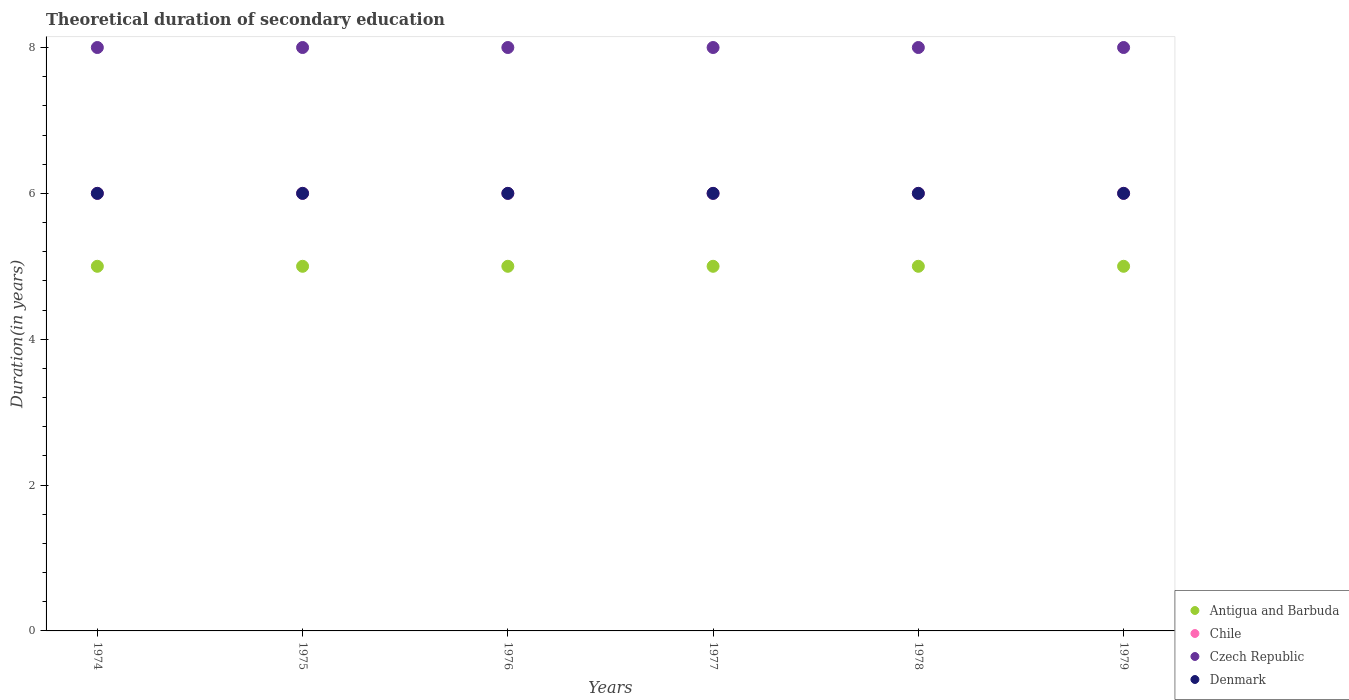How many different coloured dotlines are there?
Offer a terse response. 4. Is the number of dotlines equal to the number of legend labels?
Your answer should be very brief. Yes. What is the total theoretical duration of secondary education in Denmark in 1974?
Your answer should be compact. 6. Across all years, what is the minimum total theoretical duration of secondary education in Czech Republic?
Make the answer very short. 8. In which year was the total theoretical duration of secondary education in Antigua and Barbuda maximum?
Provide a short and direct response. 1974. In which year was the total theoretical duration of secondary education in Czech Republic minimum?
Provide a short and direct response. 1974. What is the total total theoretical duration of secondary education in Czech Republic in the graph?
Keep it short and to the point. 48. What is the difference between the total theoretical duration of secondary education in Denmark in 1979 and the total theoretical duration of secondary education in Czech Republic in 1974?
Ensure brevity in your answer.  -2. What is the average total theoretical duration of secondary education in Denmark per year?
Make the answer very short. 6. In the year 1974, what is the difference between the total theoretical duration of secondary education in Czech Republic and total theoretical duration of secondary education in Denmark?
Your answer should be compact. 2. What is the ratio of the total theoretical duration of secondary education in Czech Republic in 1976 to that in 1977?
Offer a very short reply. 1. Is the difference between the total theoretical duration of secondary education in Czech Republic in 1975 and 1976 greater than the difference between the total theoretical duration of secondary education in Denmark in 1975 and 1976?
Provide a short and direct response. No. What is the difference between the highest and the lowest total theoretical duration of secondary education in Antigua and Barbuda?
Keep it short and to the point. 0. Is it the case that in every year, the sum of the total theoretical duration of secondary education in Czech Republic and total theoretical duration of secondary education in Denmark  is greater than the sum of total theoretical duration of secondary education in Chile and total theoretical duration of secondary education in Antigua and Barbuda?
Offer a terse response. Yes. Does the total theoretical duration of secondary education in Chile monotonically increase over the years?
Your answer should be compact. No. Is the total theoretical duration of secondary education in Antigua and Barbuda strictly greater than the total theoretical duration of secondary education in Czech Republic over the years?
Make the answer very short. No. Is the total theoretical duration of secondary education in Denmark strictly less than the total theoretical duration of secondary education in Czech Republic over the years?
Offer a terse response. Yes. How many years are there in the graph?
Keep it short and to the point. 6. Are the values on the major ticks of Y-axis written in scientific E-notation?
Make the answer very short. No. Does the graph contain grids?
Your answer should be very brief. No. What is the title of the graph?
Your response must be concise. Theoretical duration of secondary education. What is the label or title of the Y-axis?
Provide a succinct answer. Duration(in years). What is the Duration(in years) in Chile in 1974?
Give a very brief answer. 6. What is the Duration(in years) of Antigua and Barbuda in 1975?
Provide a succinct answer. 5. What is the Duration(in years) in Chile in 1975?
Make the answer very short. 6. What is the Duration(in years) in Chile in 1976?
Provide a short and direct response. 6. What is the Duration(in years) in Antigua and Barbuda in 1977?
Offer a very short reply. 5. What is the Duration(in years) of Chile in 1977?
Keep it short and to the point. 6. What is the Duration(in years) of Czech Republic in 1978?
Give a very brief answer. 8. What is the Duration(in years) in Antigua and Barbuda in 1979?
Give a very brief answer. 5. What is the Duration(in years) of Chile in 1979?
Provide a short and direct response. 6. Across all years, what is the maximum Duration(in years) of Antigua and Barbuda?
Offer a terse response. 5. Across all years, what is the maximum Duration(in years) in Czech Republic?
Provide a short and direct response. 8. Across all years, what is the minimum Duration(in years) of Chile?
Your response must be concise. 6. Across all years, what is the minimum Duration(in years) of Czech Republic?
Provide a short and direct response. 8. What is the total Duration(in years) of Chile in the graph?
Your answer should be compact. 36. What is the total Duration(in years) of Czech Republic in the graph?
Make the answer very short. 48. What is the total Duration(in years) in Denmark in the graph?
Offer a very short reply. 36. What is the difference between the Duration(in years) in Antigua and Barbuda in 1974 and that in 1975?
Your answer should be compact. 0. What is the difference between the Duration(in years) in Czech Republic in 1974 and that in 1975?
Ensure brevity in your answer.  0. What is the difference between the Duration(in years) of Antigua and Barbuda in 1974 and that in 1976?
Offer a terse response. 0. What is the difference between the Duration(in years) of Denmark in 1974 and that in 1978?
Offer a very short reply. 0. What is the difference between the Duration(in years) in Chile in 1974 and that in 1979?
Offer a very short reply. 0. What is the difference between the Duration(in years) of Denmark in 1974 and that in 1979?
Ensure brevity in your answer.  0. What is the difference between the Duration(in years) in Antigua and Barbuda in 1975 and that in 1976?
Make the answer very short. 0. What is the difference between the Duration(in years) of Chile in 1975 and that in 1976?
Give a very brief answer. 0. What is the difference between the Duration(in years) in Czech Republic in 1975 and that in 1976?
Provide a short and direct response. 0. What is the difference between the Duration(in years) of Chile in 1975 and that in 1977?
Provide a short and direct response. 0. What is the difference between the Duration(in years) of Czech Republic in 1975 and that in 1977?
Give a very brief answer. 0. What is the difference between the Duration(in years) in Denmark in 1975 and that in 1977?
Provide a short and direct response. 0. What is the difference between the Duration(in years) in Chile in 1975 and that in 1978?
Make the answer very short. 0. What is the difference between the Duration(in years) in Czech Republic in 1975 and that in 1978?
Keep it short and to the point. 0. What is the difference between the Duration(in years) in Czech Republic in 1975 and that in 1979?
Keep it short and to the point. 0. What is the difference between the Duration(in years) of Denmark in 1975 and that in 1979?
Offer a very short reply. 0. What is the difference between the Duration(in years) of Antigua and Barbuda in 1976 and that in 1977?
Your answer should be compact. 0. What is the difference between the Duration(in years) of Czech Republic in 1976 and that in 1977?
Ensure brevity in your answer.  0. What is the difference between the Duration(in years) in Antigua and Barbuda in 1976 and that in 1978?
Your answer should be very brief. 0. What is the difference between the Duration(in years) in Chile in 1976 and that in 1978?
Keep it short and to the point. 0. What is the difference between the Duration(in years) in Denmark in 1976 and that in 1978?
Offer a terse response. 0. What is the difference between the Duration(in years) in Chile in 1976 and that in 1979?
Your answer should be very brief. 0. What is the difference between the Duration(in years) of Denmark in 1976 and that in 1979?
Ensure brevity in your answer.  0. What is the difference between the Duration(in years) in Antigua and Barbuda in 1977 and that in 1978?
Give a very brief answer. 0. What is the difference between the Duration(in years) in Chile in 1977 and that in 1978?
Keep it short and to the point. 0. What is the difference between the Duration(in years) in Denmark in 1977 and that in 1978?
Provide a short and direct response. 0. What is the difference between the Duration(in years) in Antigua and Barbuda in 1978 and that in 1979?
Keep it short and to the point. 0. What is the difference between the Duration(in years) in Chile in 1978 and that in 1979?
Your answer should be compact. 0. What is the difference between the Duration(in years) in Czech Republic in 1978 and that in 1979?
Offer a terse response. 0. What is the difference between the Duration(in years) of Denmark in 1978 and that in 1979?
Ensure brevity in your answer.  0. What is the difference between the Duration(in years) of Antigua and Barbuda in 1974 and the Duration(in years) of Chile in 1975?
Make the answer very short. -1. What is the difference between the Duration(in years) of Antigua and Barbuda in 1974 and the Duration(in years) of Chile in 1976?
Make the answer very short. -1. What is the difference between the Duration(in years) of Antigua and Barbuda in 1974 and the Duration(in years) of Czech Republic in 1976?
Your answer should be very brief. -3. What is the difference between the Duration(in years) of Antigua and Barbuda in 1974 and the Duration(in years) of Denmark in 1976?
Provide a succinct answer. -1. What is the difference between the Duration(in years) in Chile in 1974 and the Duration(in years) in Czech Republic in 1976?
Your answer should be compact. -2. What is the difference between the Duration(in years) of Czech Republic in 1974 and the Duration(in years) of Denmark in 1976?
Provide a succinct answer. 2. What is the difference between the Duration(in years) in Antigua and Barbuda in 1974 and the Duration(in years) in Denmark in 1977?
Your response must be concise. -1. What is the difference between the Duration(in years) in Chile in 1974 and the Duration(in years) in Czech Republic in 1977?
Give a very brief answer. -2. What is the difference between the Duration(in years) in Chile in 1974 and the Duration(in years) in Denmark in 1977?
Give a very brief answer. 0. What is the difference between the Duration(in years) in Czech Republic in 1974 and the Duration(in years) in Denmark in 1977?
Offer a terse response. 2. What is the difference between the Duration(in years) in Antigua and Barbuda in 1974 and the Duration(in years) in Denmark in 1978?
Offer a terse response. -1. What is the difference between the Duration(in years) of Chile in 1974 and the Duration(in years) of Czech Republic in 1978?
Provide a short and direct response. -2. What is the difference between the Duration(in years) in Chile in 1974 and the Duration(in years) in Denmark in 1978?
Your answer should be compact. 0. What is the difference between the Duration(in years) of Antigua and Barbuda in 1974 and the Duration(in years) of Chile in 1979?
Provide a succinct answer. -1. What is the difference between the Duration(in years) in Antigua and Barbuda in 1974 and the Duration(in years) in Czech Republic in 1979?
Provide a short and direct response. -3. What is the difference between the Duration(in years) of Antigua and Barbuda in 1974 and the Duration(in years) of Denmark in 1979?
Your answer should be very brief. -1. What is the difference between the Duration(in years) in Chile in 1974 and the Duration(in years) in Czech Republic in 1979?
Your response must be concise. -2. What is the difference between the Duration(in years) in Chile in 1974 and the Duration(in years) in Denmark in 1979?
Your answer should be very brief. 0. What is the difference between the Duration(in years) of Czech Republic in 1974 and the Duration(in years) of Denmark in 1979?
Make the answer very short. 2. What is the difference between the Duration(in years) in Chile in 1975 and the Duration(in years) in Czech Republic in 1976?
Provide a short and direct response. -2. What is the difference between the Duration(in years) in Antigua and Barbuda in 1975 and the Duration(in years) in Chile in 1977?
Your answer should be very brief. -1. What is the difference between the Duration(in years) of Antigua and Barbuda in 1975 and the Duration(in years) of Denmark in 1977?
Provide a succinct answer. -1. What is the difference between the Duration(in years) of Chile in 1975 and the Duration(in years) of Denmark in 1977?
Your answer should be compact. 0. What is the difference between the Duration(in years) in Czech Republic in 1975 and the Duration(in years) in Denmark in 1977?
Your response must be concise. 2. What is the difference between the Duration(in years) in Antigua and Barbuda in 1975 and the Duration(in years) in Czech Republic in 1978?
Ensure brevity in your answer.  -3. What is the difference between the Duration(in years) of Antigua and Barbuda in 1975 and the Duration(in years) of Denmark in 1978?
Give a very brief answer. -1. What is the difference between the Duration(in years) in Chile in 1975 and the Duration(in years) in Czech Republic in 1978?
Provide a short and direct response. -2. What is the difference between the Duration(in years) in Chile in 1975 and the Duration(in years) in Denmark in 1978?
Give a very brief answer. 0. What is the difference between the Duration(in years) of Antigua and Barbuda in 1975 and the Duration(in years) of Chile in 1979?
Give a very brief answer. -1. What is the difference between the Duration(in years) in Antigua and Barbuda in 1975 and the Duration(in years) in Denmark in 1979?
Your answer should be very brief. -1. What is the difference between the Duration(in years) of Czech Republic in 1975 and the Duration(in years) of Denmark in 1979?
Provide a short and direct response. 2. What is the difference between the Duration(in years) of Antigua and Barbuda in 1976 and the Duration(in years) of Czech Republic in 1977?
Ensure brevity in your answer.  -3. What is the difference between the Duration(in years) of Chile in 1976 and the Duration(in years) of Czech Republic in 1977?
Keep it short and to the point. -2. What is the difference between the Duration(in years) of Chile in 1976 and the Duration(in years) of Denmark in 1977?
Your answer should be compact. 0. What is the difference between the Duration(in years) in Antigua and Barbuda in 1976 and the Duration(in years) in Chile in 1978?
Offer a terse response. -1. What is the difference between the Duration(in years) of Antigua and Barbuda in 1976 and the Duration(in years) of Czech Republic in 1978?
Your answer should be compact. -3. What is the difference between the Duration(in years) in Antigua and Barbuda in 1976 and the Duration(in years) in Chile in 1979?
Your answer should be compact. -1. What is the difference between the Duration(in years) of Antigua and Barbuda in 1976 and the Duration(in years) of Czech Republic in 1979?
Provide a short and direct response. -3. What is the difference between the Duration(in years) in Antigua and Barbuda in 1976 and the Duration(in years) in Denmark in 1979?
Keep it short and to the point. -1. What is the difference between the Duration(in years) in Chile in 1976 and the Duration(in years) in Czech Republic in 1979?
Your answer should be compact. -2. What is the difference between the Duration(in years) of Antigua and Barbuda in 1977 and the Duration(in years) of Denmark in 1978?
Your response must be concise. -1. What is the difference between the Duration(in years) in Chile in 1977 and the Duration(in years) in Czech Republic in 1978?
Provide a short and direct response. -2. What is the difference between the Duration(in years) of Chile in 1977 and the Duration(in years) of Denmark in 1978?
Ensure brevity in your answer.  0. What is the difference between the Duration(in years) of Antigua and Barbuda in 1977 and the Duration(in years) of Czech Republic in 1979?
Your response must be concise. -3. What is the difference between the Duration(in years) in Chile in 1977 and the Duration(in years) in Czech Republic in 1979?
Offer a terse response. -2. What is the difference between the Duration(in years) of Antigua and Barbuda in 1978 and the Duration(in years) of Chile in 1979?
Your answer should be compact. -1. What is the difference between the Duration(in years) of Chile in 1978 and the Duration(in years) of Denmark in 1979?
Provide a succinct answer. 0. What is the difference between the Duration(in years) in Czech Republic in 1978 and the Duration(in years) in Denmark in 1979?
Your response must be concise. 2. What is the average Duration(in years) of Antigua and Barbuda per year?
Your answer should be very brief. 5. What is the average Duration(in years) in Chile per year?
Your response must be concise. 6. What is the average Duration(in years) of Czech Republic per year?
Your response must be concise. 8. What is the average Duration(in years) of Denmark per year?
Make the answer very short. 6. In the year 1974, what is the difference between the Duration(in years) of Antigua and Barbuda and Duration(in years) of Chile?
Provide a short and direct response. -1. In the year 1974, what is the difference between the Duration(in years) of Antigua and Barbuda and Duration(in years) of Denmark?
Offer a terse response. -1. In the year 1974, what is the difference between the Duration(in years) in Chile and Duration(in years) in Czech Republic?
Give a very brief answer. -2. In the year 1974, what is the difference between the Duration(in years) of Chile and Duration(in years) of Denmark?
Provide a short and direct response. 0. In the year 1974, what is the difference between the Duration(in years) of Czech Republic and Duration(in years) of Denmark?
Keep it short and to the point. 2. In the year 1975, what is the difference between the Duration(in years) of Antigua and Barbuda and Duration(in years) of Chile?
Your response must be concise. -1. In the year 1975, what is the difference between the Duration(in years) of Antigua and Barbuda and Duration(in years) of Czech Republic?
Offer a terse response. -3. In the year 1975, what is the difference between the Duration(in years) of Czech Republic and Duration(in years) of Denmark?
Keep it short and to the point. 2. In the year 1976, what is the difference between the Duration(in years) of Antigua and Barbuda and Duration(in years) of Chile?
Keep it short and to the point. -1. In the year 1976, what is the difference between the Duration(in years) of Antigua and Barbuda and Duration(in years) of Denmark?
Keep it short and to the point. -1. In the year 1976, what is the difference between the Duration(in years) of Chile and Duration(in years) of Denmark?
Provide a short and direct response. 0. In the year 1976, what is the difference between the Duration(in years) in Czech Republic and Duration(in years) in Denmark?
Offer a terse response. 2. In the year 1977, what is the difference between the Duration(in years) in Antigua and Barbuda and Duration(in years) in Chile?
Offer a very short reply. -1. In the year 1977, what is the difference between the Duration(in years) in Antigua and Barbuda and Duration(in years) in Denmark?
Offer a terse response. -1. In the year 1978, what is the difference between the Duration(in years) of Antigua and Barbuda and Duration(in years) of Chile?
Give a very brief answer. -1. In the year 1978, what is the difference between the Duration(in years) in Chile and Duration(in years) in Czech Republic?
Your response must be concise. -2. In the year 1978, what is the difference between the Duration(in years) of Czech Republic and Duration(in years) of Denmark?
Ensure brevity in your answer.  2. In the year 1979, what is the difference between the Duration(in years) in Chile and Duration(in years) in Denmark?
Ensure brevity in your answer.  0. In the year 1979, what is the difference between the Duration(in years) in Czech Republic and Duration(in years) in Denmark?
Your response must be concise. 2. What is the ratio of the Duration(in years) of Chile in 1974 to that in 1975?
Your answer should be compact. 1. What is the ratio of the Duration(in years) of Czech Republic in 1974 to that in 1975?
Provide a succinct answer. 1. What is the ratio of the Duration(in years) in Denmark in 1974 to that in 1976?
Your answer should be compact. 1. What is the ratio of the Duration(in years) in Antigua and Barbuda in 1974 to that in 1977?
Your answer should be very brief. 1. What is the ratio of the Duration(in years) of Denmark in 1974 to that in 1977?
Ensure brevity in your answer.  1. What is the ratio of the Duration(in years) in Antigua and Barbuda in 1974 to that in 1978?
Your answer should be very brief. 1. What is the ratio of the Duration(in years) of Denmark in 1974 to that in 1978?
Provide a succinct answer. 1. What is the ratio of the Duration(in years) of Czech Republic in 1974 to that in 1979?
Your answer should be very brief. 1. What is the ratio of the Duration(in years) of Denmark in 1974 to that in 1979?
Your answer should be compact. 1. What is the ratio of the Duration(in years) of Antigua and Barbuda in 1975 to that in 1976?
Your response must be concise. 1. What is the ratio of the Duration(in years) of Chile in 1975 to that in 1976?
Keep it short and to the point. 1. What is the ratio of the Duration(in years) of Chile in 1975 to that in 1977?
Offer a terse response. 1. What is the ratio of the Duration(in years) in Czech Republic in 1975 to that in 1977?
Make the answer very short. 1. What is the ratio of the Duration(in years) of Chile in 1975 to that in 1978?
Your answer should be compact. 1. What is the ratio of the Duration(in years) of Denmark in 1975 to that in 1978?
Provide a succinct answer. 1. What is the ratio of the Duration(in years) in Chile in 1975 to that in 1979?
Your answer should be very brief. 1. What is the ratio of the Duration(in years) in Czech Republic in 1975 to that in 1979?
Your answer should be compact. 1. What is the ratio of the Duration(in years) of Antigua and Barbuda in 1976 to that in 1977?
Provide a succinct answer. 1. What is the ratio of the Duration(in years) in Czech Republic in 1976 to that in 1977?
Provide a short and direct response. 1. What is the ratio of the Duration(in years) of Denmark in 1976 to that in 1977?
Provide a short and direct response. 1. What is the ratio of the Duration(in years) in Antigua and Barbuda in 1976 to that in 1978?
Your response must be concise. 1. What is the ratio of the Duration(in years) of Denmark in 1976 to that in 1978?
Your answer should be very brief. 1. What is the ratio of the Duration(in years) of Antigua and Barbuda in 1977 to that in 1978?
Ensure brevity in your answer.  1. What is the ratio of the Duration(in years) of Czech Republic in 1977 to that in 1978?
Provide a succinct answer. 1. What is the ratio of the Duration(in years) of Denmark in 1977 to that in 1978?
Provide a succinct answer. 1. What is the ratio of the Duration(in years) in Chile in 1977 to that in 1979?
Provide a short and direct response. 1. What is the ratio of the Duration(in years) in Antigua and Barbuda in 1978 to that in 1979?
Give a very brief answer. 1. What is the ratio of the Duration(in years) of Chile in 1978 to that in 1979?
Ensure brevity in your answer.  1. What is the ratio of the Duration(in years) in Denmark in 1978 to that in 1979?
Your response must be concise. 1. What is the difference between the highest and the second highest Duration(in years) in Antigua and Barbuda?
Offer a very short reply. 0. What is the difference between the highest and the second highest Duration(in years) in Czech Republic?
Ensure brevity in your answer.  0. What is the difference between the highest and the second highest Duration(in years) of Denmark?
Your response must be concise. 0. What is the difference between the highest and the lowest Duration(in years) of Antigua and Barbuda?
Provide a succinct answer. 0. What is the difference between the highest and the lowest Duration(in years) in Chile?
Give a very brief answer. 0. What is the difference between the highest and the lowest Duration(in years) of Czech Republic?
Your answer should be very brief. 0. 